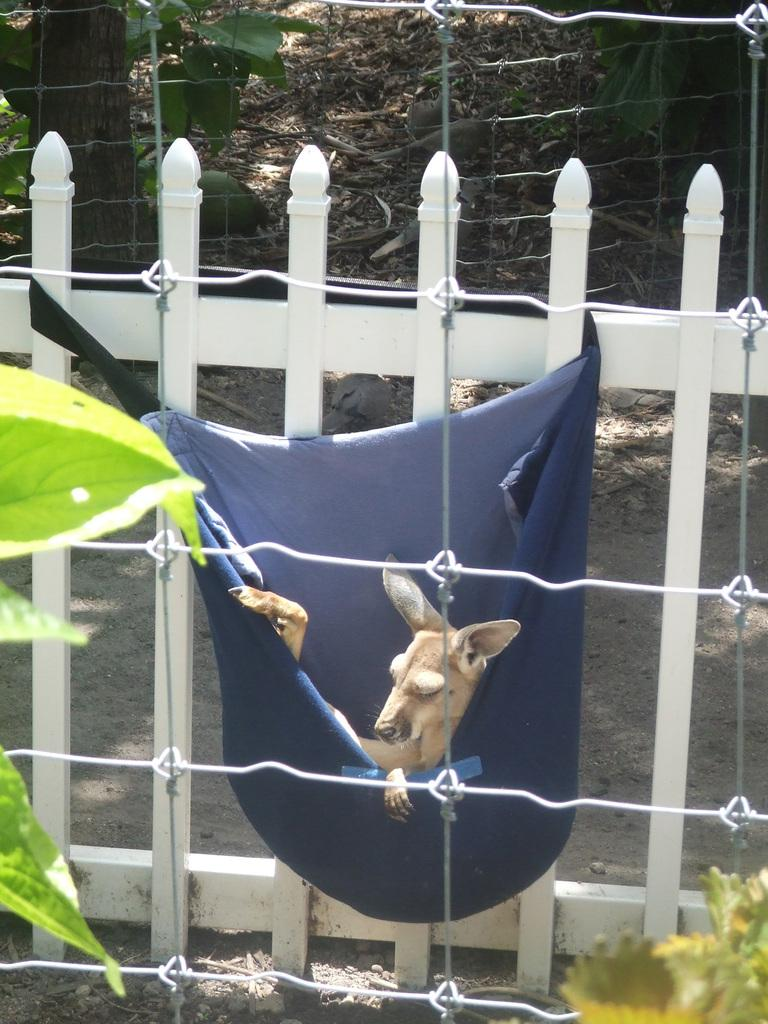What is the dog in the image contained within? The dog is in a blue color bag. Where is the bag with the dog hanging? The bag is hanged on a white color railing. What can be seen in the background of the image? There is a fence in the image. What type of vegetation is present on the ground? There are plants on the ground. What type of agreement is being discussed in the image? There is no discussion or agreement present in the image; it features a dog in a blue bag hanging on a white railing, with a fence and plants in the background. 